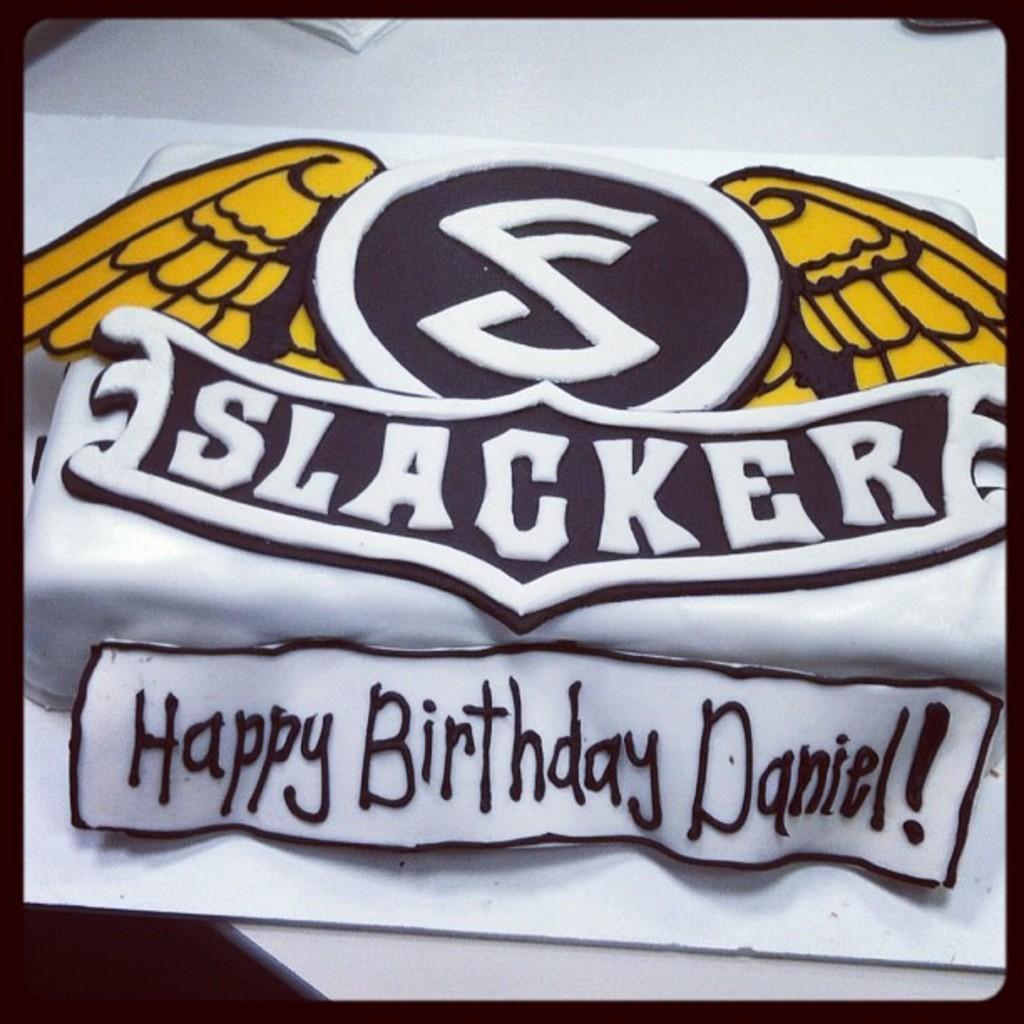Can you describe this image briefly? There is a logo in the center of the image and there is text at the bottom side. 